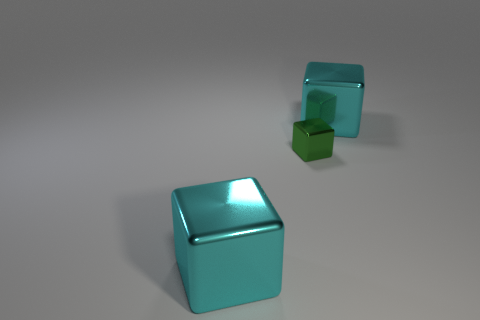Add 2 small green metallic blocks. How many objects exist? 5 Add 3 small metallic cubes. How many small metallic cubes exist? 4 Subtract 0 brown spheres. How many objects are left? 3 Subtract all small red matte blocks. Subtract all green metal cubes. How many objects are left? 2 Add 1 tiny green things. How many tiny green things are left? 2 